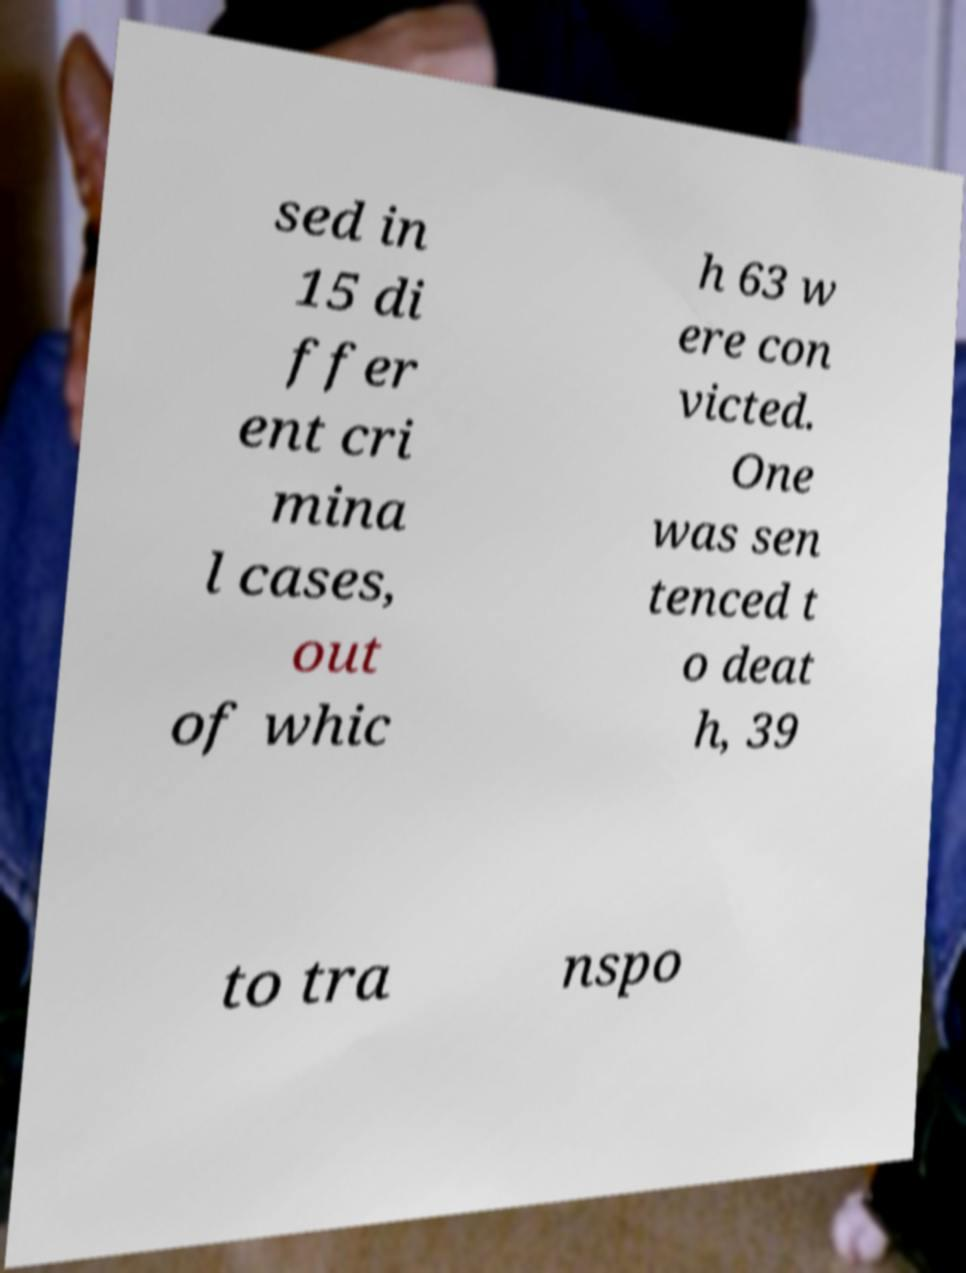Please read and relay the text visible in this image. What does it say? sed in 15 di ffer ent cri mina l cases, out of whic h 63 w ere con victed. One was sen tenced t o deat h, 39 to tra nspo 